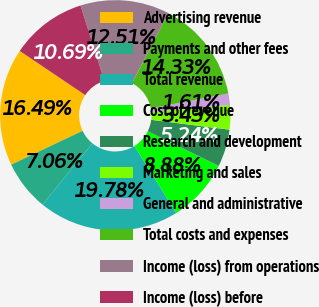Convert chart to OTSL. <chart><loc_0><loc_0><loc_500><loc_500><pie_chart><fcel>Advertising revenue<fcel>Payments and other fees<fcel>Total revenue<fcel>Cost of revenue<fcel>Research and development<fcel>Marketing and sales<fcel>General and administrative<fcel>Total costs and expenses<fcel>Income (loss) from operations<fcel>Income (loss) before<nl><fcel>16.49%<fcel>7.06%<fcel>19.78%<fcel>8.88%<fcel>5.24%<fcel>3.43%<fcel>1.61%<fcel>14.33%<fcel>12.51%<fcel>10.69%<nl></chart> 